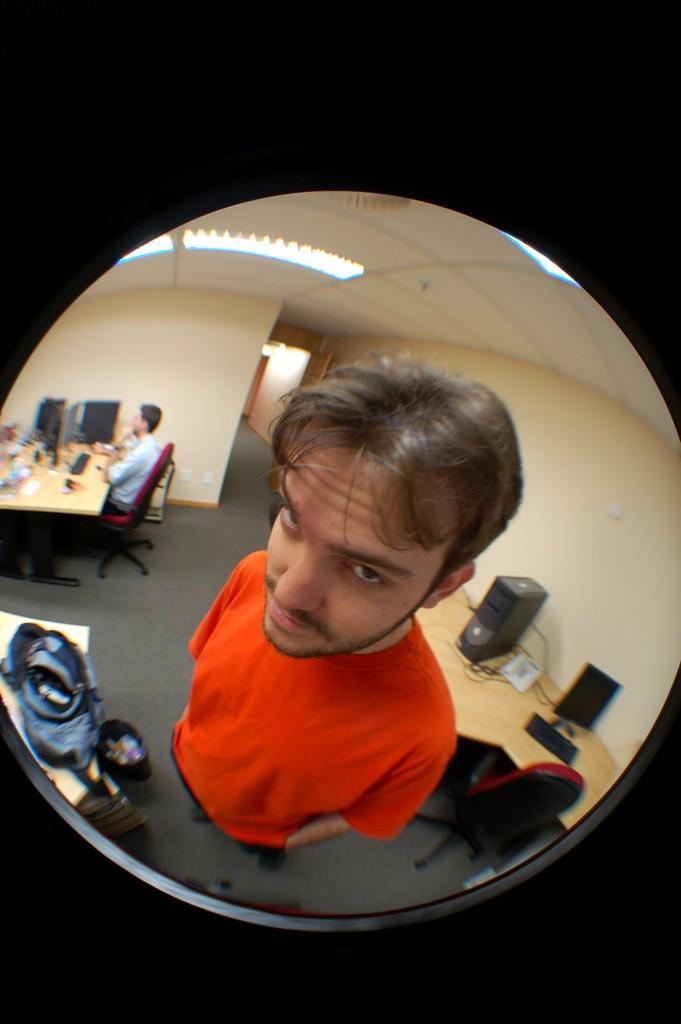Could you give a brief overview of what you see in this image? In this image I see 2 men, in which one of them is standing and another one is sitting, I can also see there are lot of tables and monitors, bags, CPU and few things on it. In the background I see the wall and the lights on the ceiling. 